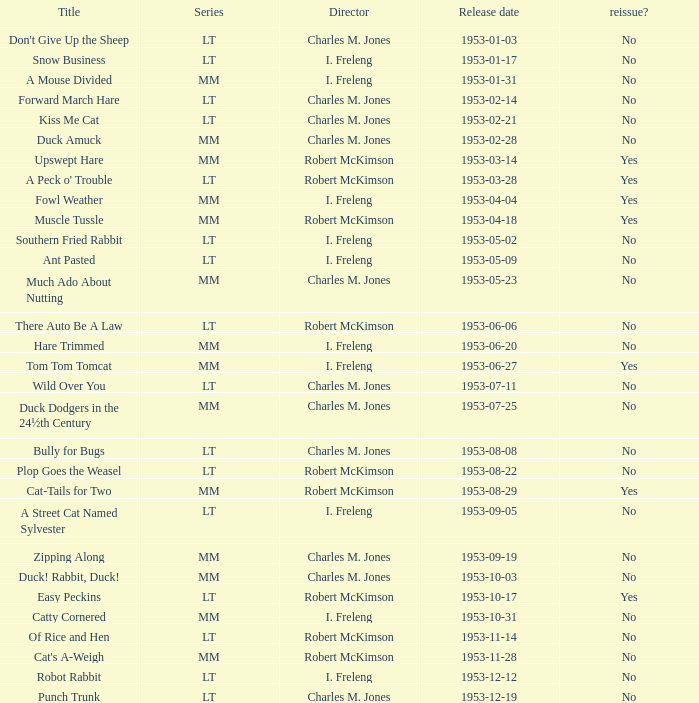What is the launch date for upswept hare? 1953-03-14. 